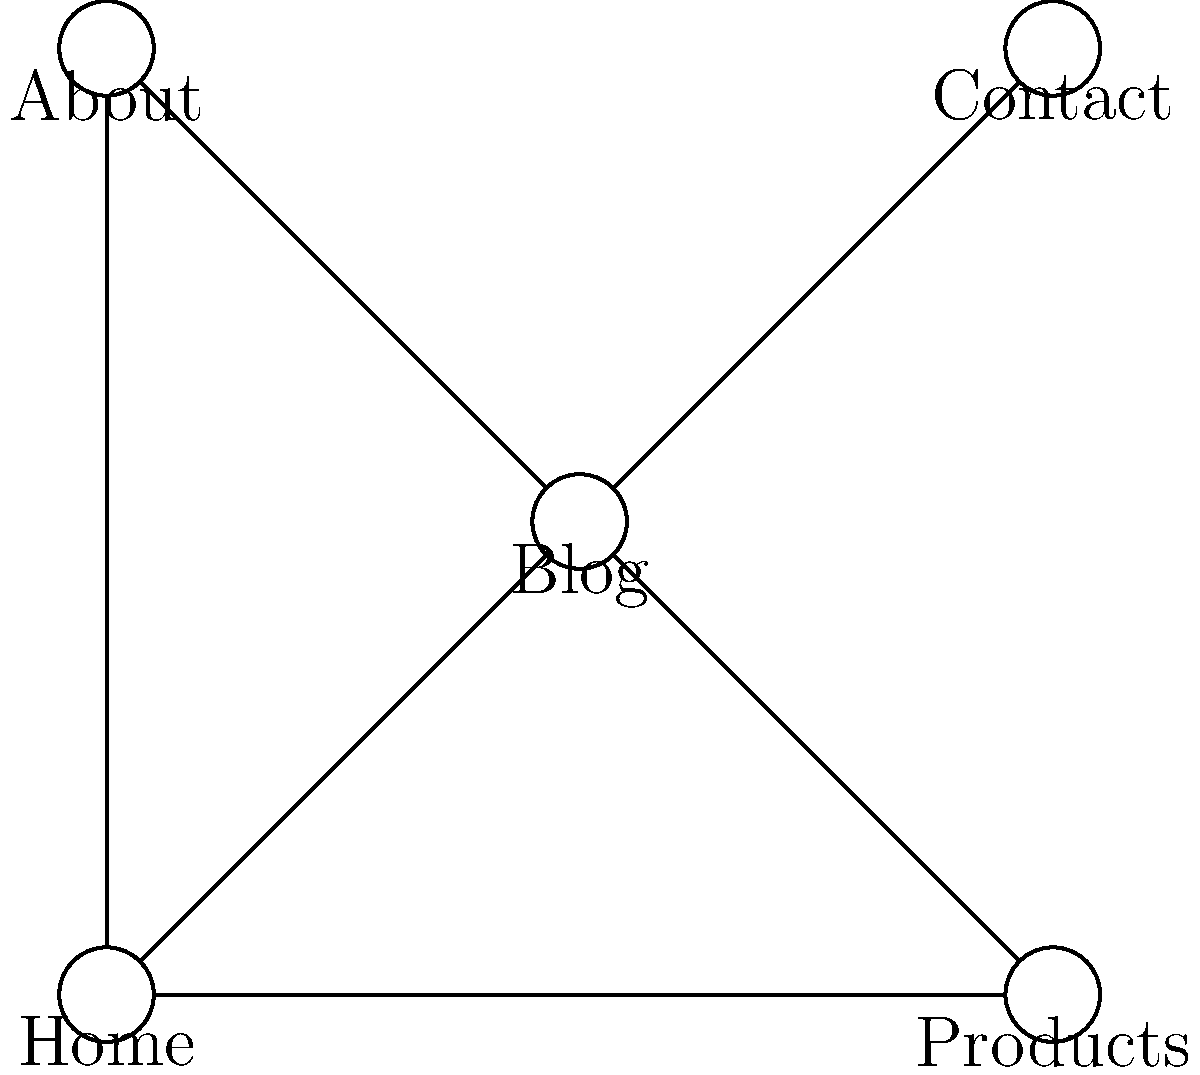As a successful online entrepreneur, you're redesigning your website's structure for optimal user experience. Given the topology shown in the diagram, which represents the connections between different pages of your website, what is the maximum number of clicks required to navigate from the Home page to any other page on the site? To determine the maximum number of clicks required to navigate from the Home page to any other page, we need to analyze the structure of the website topology:

1. First, identify all the pages directly connected to the Home page:
   - Home to Products: 1 click
   - Home to Blog: 1 click
   - Home to About: 1 click
   - Home to Contact: 1 click

2. Now, check if there are any pages that require more than one click to reach from Home:
   - All pages are directly connected to Home, so there are no pages that require more than one click.

3. Calculate the maximum number of clicks:
   - Since all pages are directly accessible from Home, the maximum number of clicks is 1.

4. Verify that there are no longer paths:
   - Although there are additional connections (e.g., Blog to Products, Blog to About, Blog to Contact), these do not create longer paths from Home to any page.

Therefore, the maximum number of clicks required to navigate from the Home page to any other page on the site is 1.
Answer: 1 click 